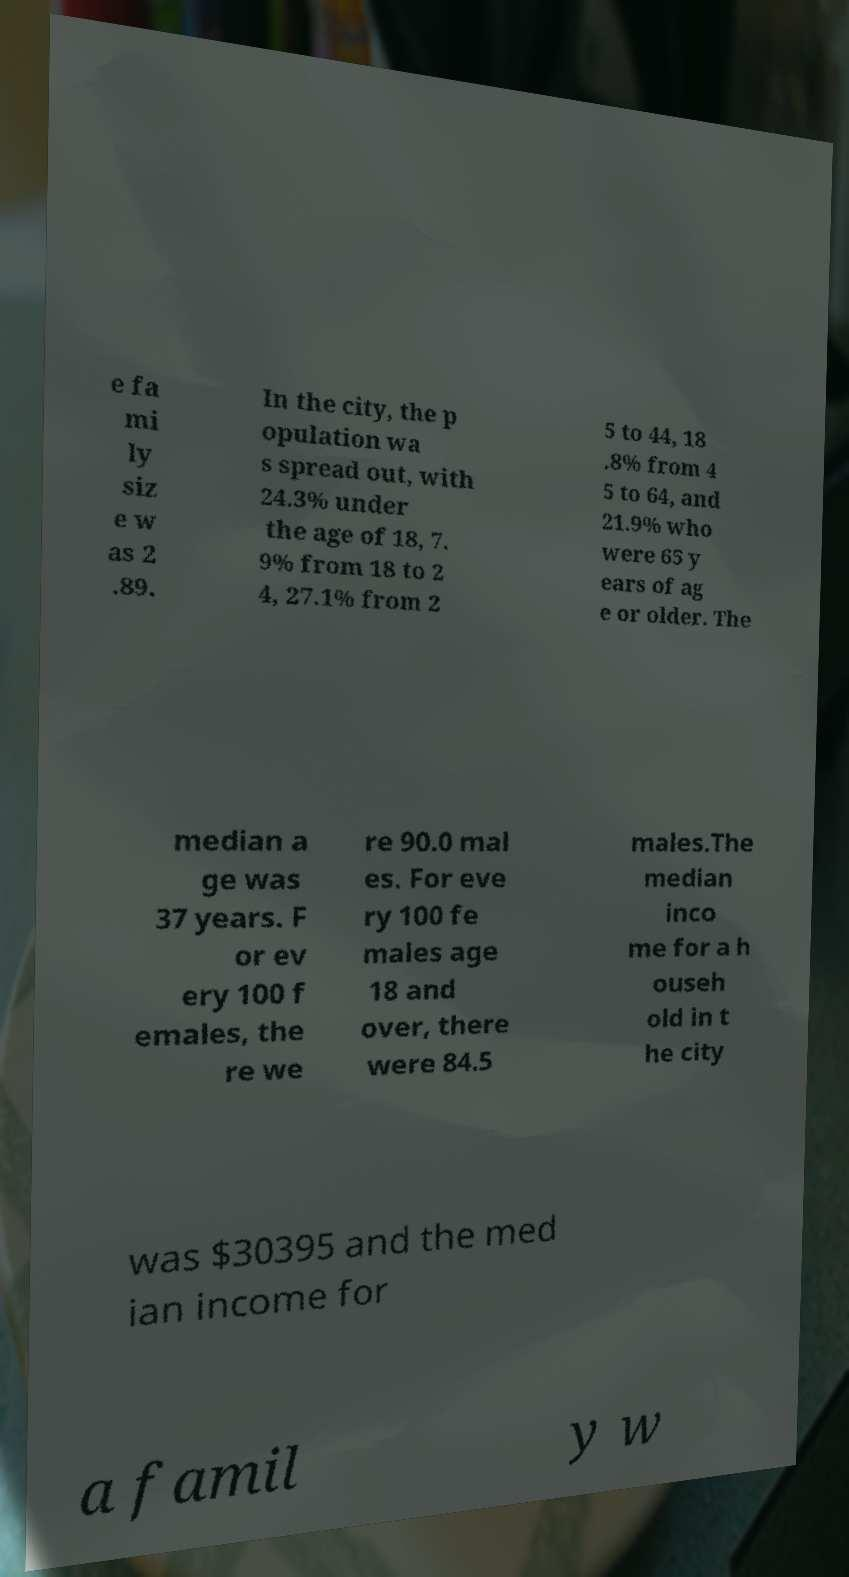I need the written content from this picture converted into text. Can you do that? e fa mi ly siz e w as 2 .89. In the city, the p opulation wa s spread out, with 24.3% under the age of 18, 7. 9% from 18 to 2 4, 27.1% from 2 5 to 44, 18 .8% from 4 5 to 64, and 21.9% who were 65 y ears of ag e or older. The median a ge was 37 years. F or ev ery 100 f emales, the re we re 90.0 mal es. For eve ry 100 fe males age 18 and over, there were 84.5 males.The median inco me for a h ouseh old in t he city was $30395 and the med ian income for a famil y w 